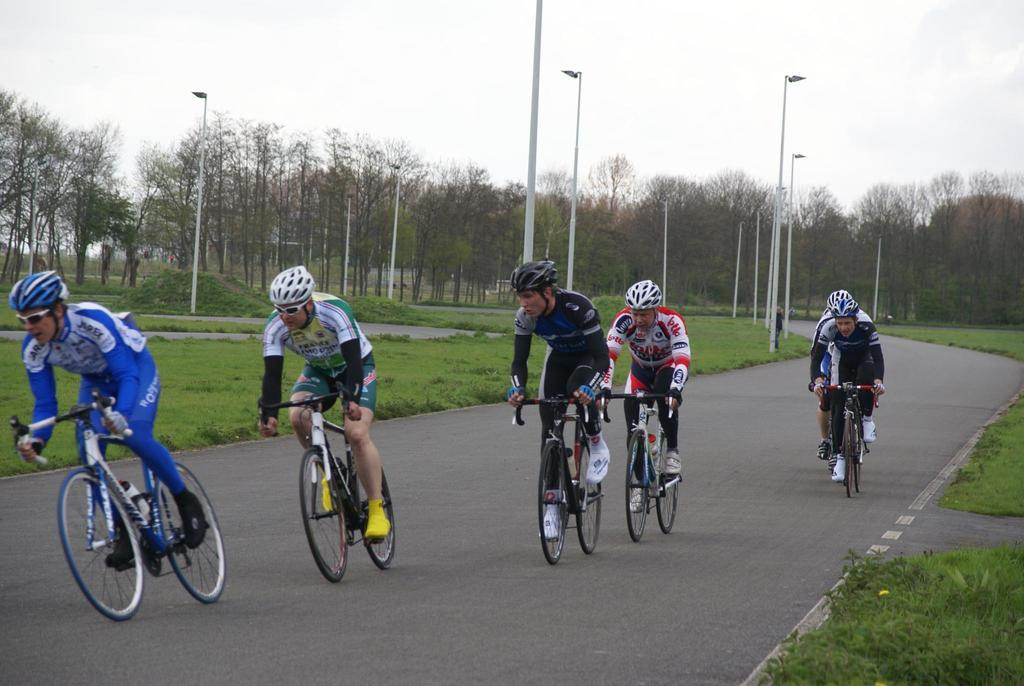What are the people in the foreground of the image doing? The people in the foreground of the image are cycling. What can be seen in the background of the image? There are trees, grassland, poles, and the sky visible in the background of the image. Can you describe the bottom right side of the image? The bottom right side of the image appears to be grassland. What type of committee can be seen in the image? There is no committee present in the image; it features people cycling and various background elements. Is there a train visible in the image? No, there is no train present in the image. 